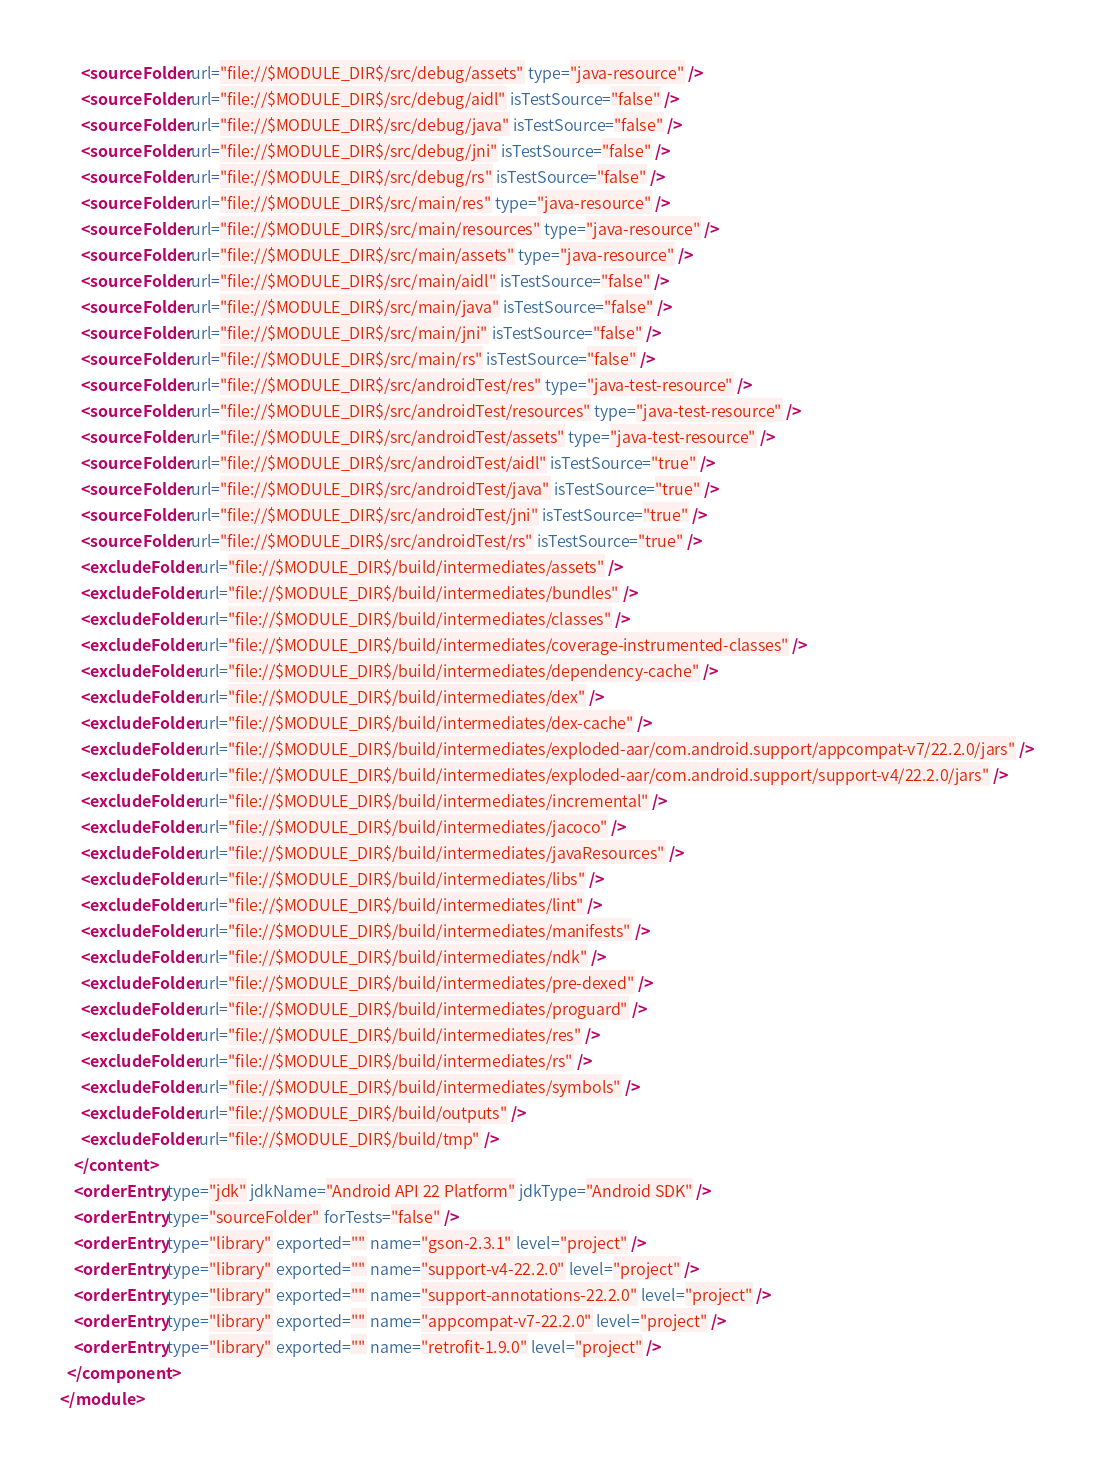<code> <loc_0><loc_0><loc_500><loc_500><_XML_>      <sourceFolder url="file://$MODULE_DIR$/src/debug/assets" type="java-resource" />
      <sourceFolder url="file://$MODULE_DIR$/src/debug/aidl" isTestSource="false" />
      <sourceFolder url="file://$MODULE_DIR$/src/debug/java" isTestSource="false" />
      <sourceFolder url="file://$MODULE_DIR$/src/debug/jni" isTestSource="false" />
      <sourceFolder url="file://$MODULE_DIR$/src/debug/rs" isTestSource="false" />
      <sourceFolder url="file://$MODULE_DIR$/src/main/res" type="java-resource" />
      <sourceFolder url="file://$MODULE_DIR$/src/main/resources" type="java-resource" />
      <sourceFolder url="file://$MODULE_DIR$/src/main/assets" type="java-resource" />
      <sourceFolder url="file://$MODULE_DIR$/src/main/aidl" isTestSource="false" />
      <sourceFolder url="file://$MODULE_DIR$/src/main/java" isTestSource="false" />
      <sourceFolder url="file://$MODULE_DIR$/src/main/jni" isTestSource="false" />
      <sourceFolder url="file://$MODULE_DIR$/src/main/rs" isTestSource="false" />
      <sourceFolder url="file://$MODULE_DIR$/src/androidTest/res" type="java-test-resource" />
      <sourceFolder url="file://$MODULE_DIR$/src/androidTest/resources" type="java-test-resource" />
      <sourceFolder url="file://$MODULE_DIR$/src/androidTest/assets" type="java-test-resource" />
      <sourceFolder url="file://$MODULE_DIR$/src/androidTest/aidl" isTestSource="true" />
      <sourceFolder url="file://$MODULE_DIR$/src/androidTest/java" isTestSource="true" />
      <sourceFolder url="file://$MODULE_DIR$/src/androidTest/jni" isTestSource="true" />
      <sourceFolder url="file://$MODULE_DIR$/src/androidTest/rs" isTestSource="true" />
      <excludeFolder url="file://$MODULE_DIR$/build/intermediates/assets" />
      <excludeFolder url="file://$MODULE_DIR$/build/intermediates/bundles" />
      <excludeFolder url="file://$MODULE_DIR$/build/intermediates/classes" />
      <excludeFolder url="file://$MODULE_DIR$/build/intermediates/coverage-instrumented-classes" />
      <excludeFolder url="file://$MODULE_DIR$/build/intermediates/dependency-cache" />
      <excludeFolder url="file://$MODULE_DIR$/build/intermediates/dex" />
      <excludeFolder url="file://$MODULE_DIR$/build/intermediates/dex-cache" />
      <excludeFolder url="file://$MODULE_DIR$/build/intermediates/exploded-aar/com.android.support/appcompat-v7/22.2.0/jars" />
      <excludeFolder url="file://$MODULE_DIR$/build/intermediates/exploded-aar/com.android.support/support-v4/22.2.0/jars" />
      <excludeFolder url="file://$MODULE_DIR$/build/intermediates/incremental" />
      <excludeFolder url="file://$MODULE_DIR$/build/intermediates/jacoco" />
      <excludeFolder url="file://$MODULE_DIR$/build/intermediates/javaResources" />
      <excludeFolder url="file://$MODULE_DIR$/build/intermediates/libs" />
      <excludeFolder url="file://$MODULE_DIR$/build/intermediates/lint" />
      <excludeFolder url="file://$MODULE_DIR$/build/intermediates/manifests" />
      <excludeFolder url="file://$MODULE_DIR$/build/intermediates/ndk" />
      <excludeFolder url="file://$MODULE_DIR$/build/intermediates/pre-dexed" />
      <excludeFolder url="file://$MODULE_DIR$/build/intermediates/proguard" />
      <excludeFolder url="file://$MODULE_DIR$/build/intermediates/res" />
      <excludeFolder url="file://$MODULE_DIR$/build/intermediates/rs" />
      <excludeFolder url="file://$MODULE_DIR$/build/intermediates/symbols" />
      <excludeFolder url="file://$MODULE_DIR$/build/outputs" />
      <excludeFolder url="file://$MODULE_DIR$/build/tmp" />
    </content>
    <orderEntry type="jdk" jdkName="Android API 22 Platform" jdkType="Android SDK" />
    <orderEntry type="sourceFolder" forTests="false" />
    <orderEntry type="library" exported="" name="gson-2.3.1" level="project" />
    <orderEntry type="library" exported="" name="support-v4-22.2.0" level="project" />
    <orderEntry type="library" exported="" name="support-annotations-22.2.0" level="project" />
    <orderEntry type="library" exported="" name="appcompat-v7-22.2.0" level="project" />
    <orderEntry type="library" exported="" name="retrofit-1.9.0" level="project" />
  </component>
</module></code> 